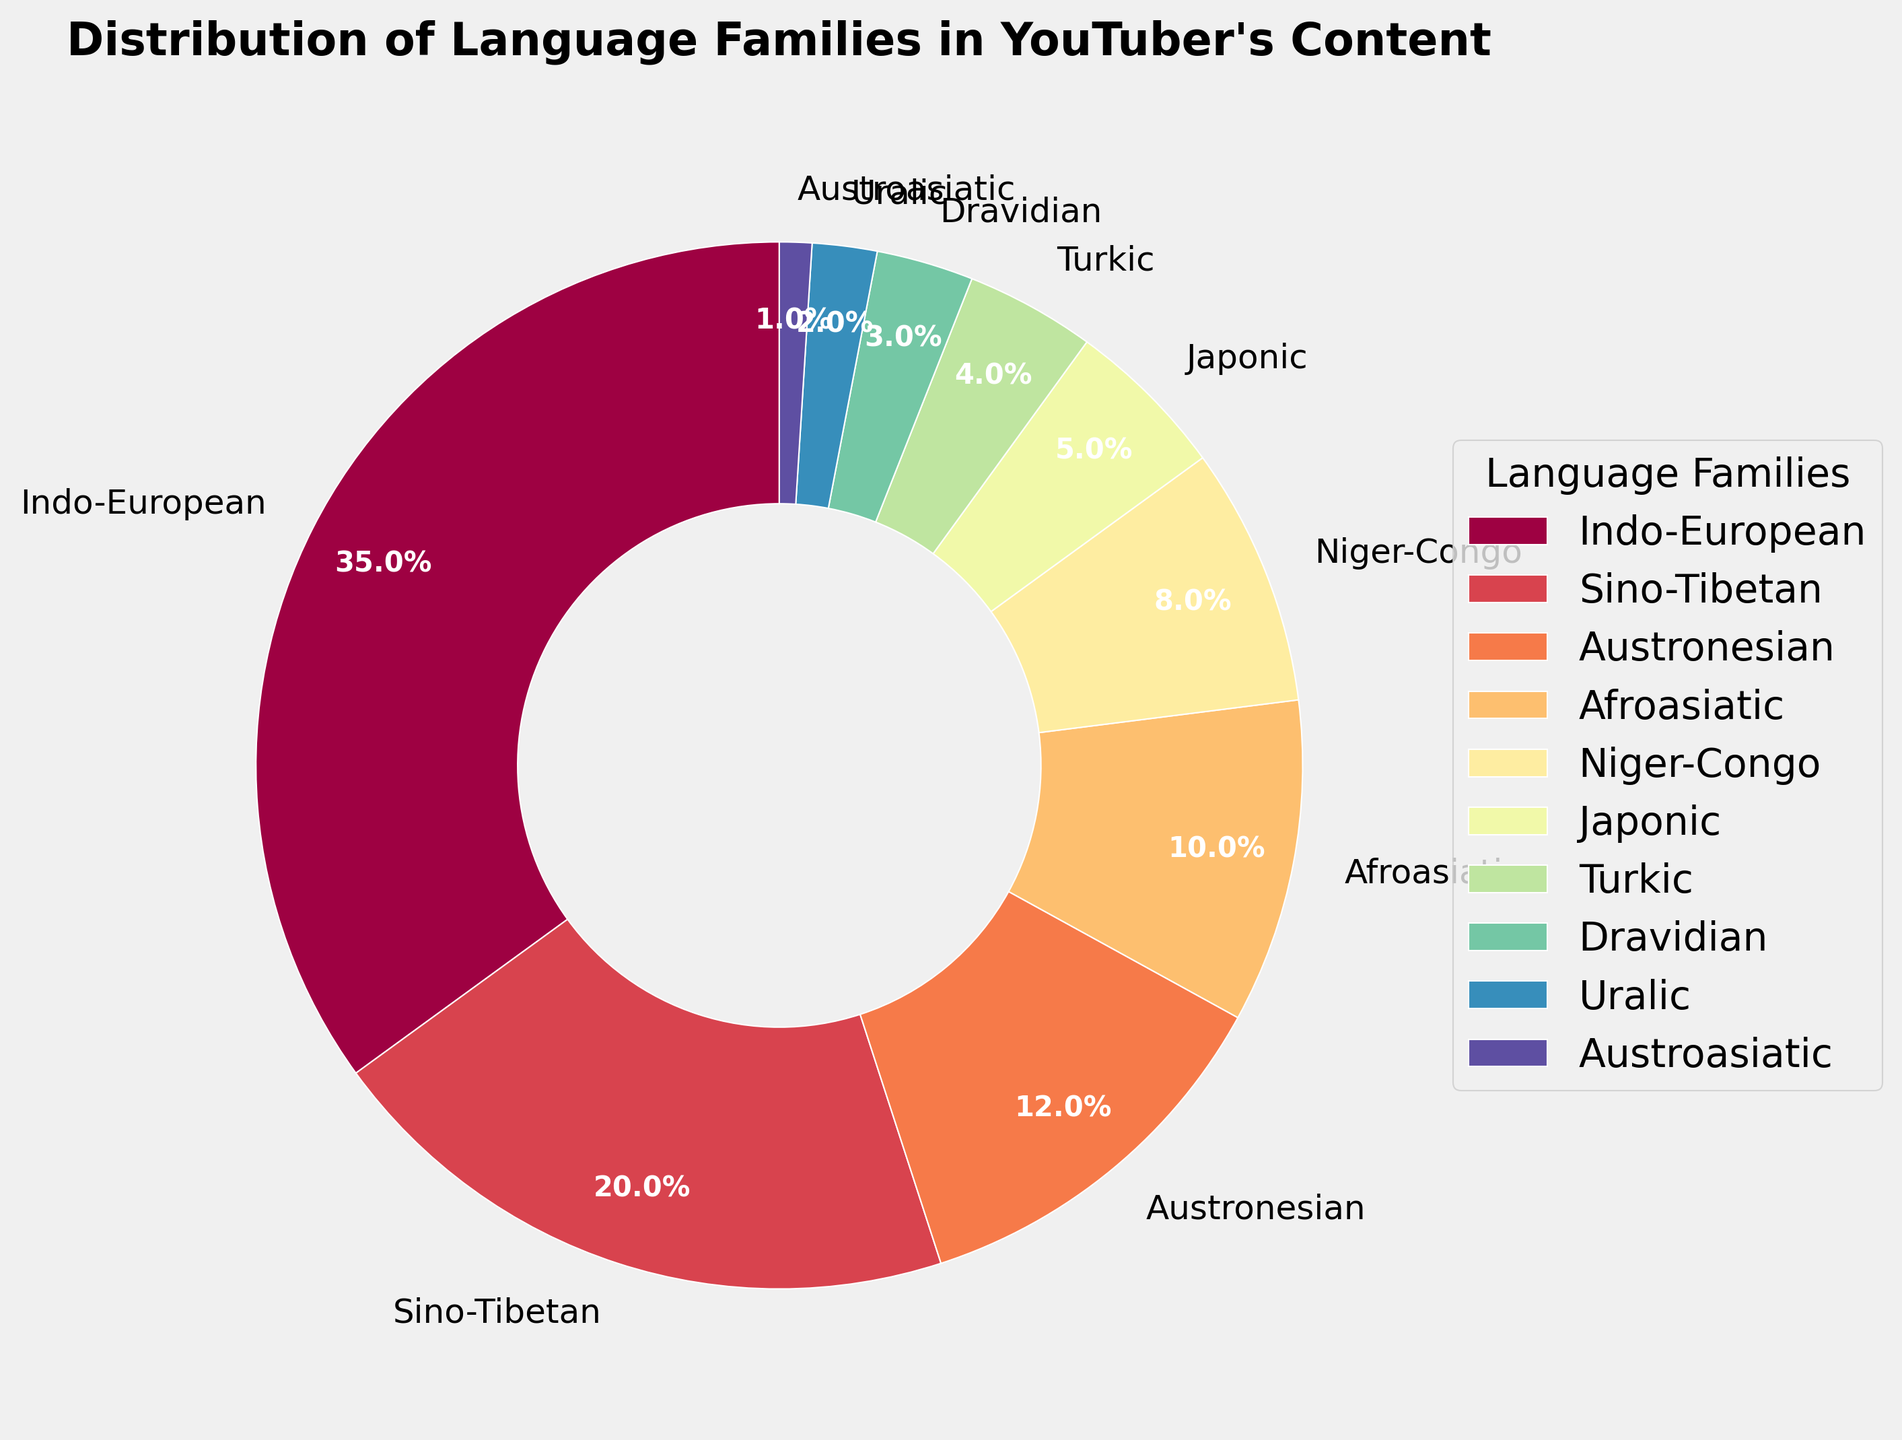What's the largest language family represented in the chart? The pie chart shows the percentage distribution of different language families. The largest wedge on the pie chart is labeled "Indo-European," and it constitutes 35% of the total.
Answer: Indo-European What is the sum of the percentages of the two smallest language families? The pie chart lists their percentages: Austroasiatic (1%) and Uralic (2%). Summing these gives 1% + 2% = 3%.
Answer: 3% Which language family is more represented in the content: Japonic or Turkic? By referring to the pie chart, Japonic has a slice of 5%, whereas Turkic has a slice of 4%. 5% is greater than 4%, so Japonic is more represented.
Answer: Japonic How many language families have a representation of less than 5%? The pie chart shows the percentages of the language families. Japonic (5%), Turkic (4%), Dravidian (3%), Uralic (2%), and Austroasiatic (1%) are less than 5%. In total, 5 families have less than 5%.
Answer: 5 What is the percentage difference between the Indo-European and Afroasiatic language families? The percentages are 35% for Indo-European and 10% for Afroasiatic. The difference is 35% - 10% = 25%.
Answer: 25% Which three language families have percentages adding up to exactly one-third of the total content? The pie chart shows Austronesian (12%), Afroasiatic (10%), and Niger-Congo (8%). Adding these gives 12% + 10% + 8% = 30%, which is one-third of the total (100%).
Answer: Austronesian, Afroasiatic, Niger-Congo Are there more language families represented in this content above or below 10%? By referencing the pie chart, above 10% are Indo-European (35%), Sino-Tibetan (20%), and Austronesian (12%) (3 families); below 10% are Afroasiatic (10%), Niger-Congo (8%), Japonic (5%), Turkic (4%), Dravidian (3%), Uralic (2%), and Austroasiatic (1%) (7 families).
Answer: Below 10% Is the Sino-Tibetan representation less than or greater than twice the percentage of the Niger-Congo family? Sino-Tibetan accounts for 20%, and Niger-Congo accounts for 8%. Twice the percentage of Niger-Congo is 8% * 2 = 16%. 20% (Sino-Tibetan) is greater than 16%.
Answer: Greater Does the combined representation of Turkic and Dravidian families equal the representation of any other language family? Turkic is 4% and Dravidian is 3%. Their combined representation is 4% + 3% = 7%. No single language family in the chart has a 7% representation.
Answer: No What's the average percentage of language families represented by those with less than 10%? The percentages for Afroasiatic (10%), Niger-Congo (8%), Japonic (5%), Turkic (4%), Dravidian (3%), Uralic (2%), and Austroasiatic (1%) add up to 33%. Excluding Afroasiatic (10%), the remaining are 8%, 5%, 4%, 3%, 2%, 1%, totaling 23%. Dividing by the 6 families gives an average: 23% / 6 ≈ 3.83%.
Answer: 3.83% 